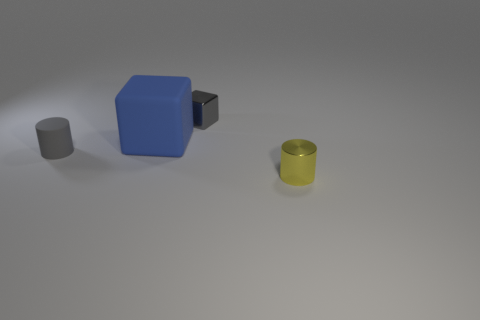There is a matte object that is the same color as the tiny cube; what is its shape?
Your answer should be compact. Cylinder. Is there anything else of the same color as the rubber cylinder?
Give a very brief answer. Yes. There is a cylinder behind the object on the right side of the tiny metal object that is behind the yellow metallic cylinder; what is it made of?
Offer a terse response. Rubber. What number of metallic things are either big gray balls or gray cubes?
Give a very brief answer. 1. Is the color of the small block the same as the small rubber cylinder?
Keep it short and to the point. Yes. What number of things are tiny red shiny objects or matte objects that are left of the large blue matte block?
Keep it short and to the point. 1. There is a thing that is right of the gray cube; is its size the same as the small matte cylinder?
Your response must be concise. Yes. How many brown things are spheres or rubber blocks?
Give a very brief answer. 0. There is a shiny object on the left side of the tiny yellow thing; is it the same color as the small rubber cylinder?
Provide a short and direct response. Yes. What is the shape of the yellow thing that is made of the same material as the small block?
Keep it short and to the point. Cylinder. 